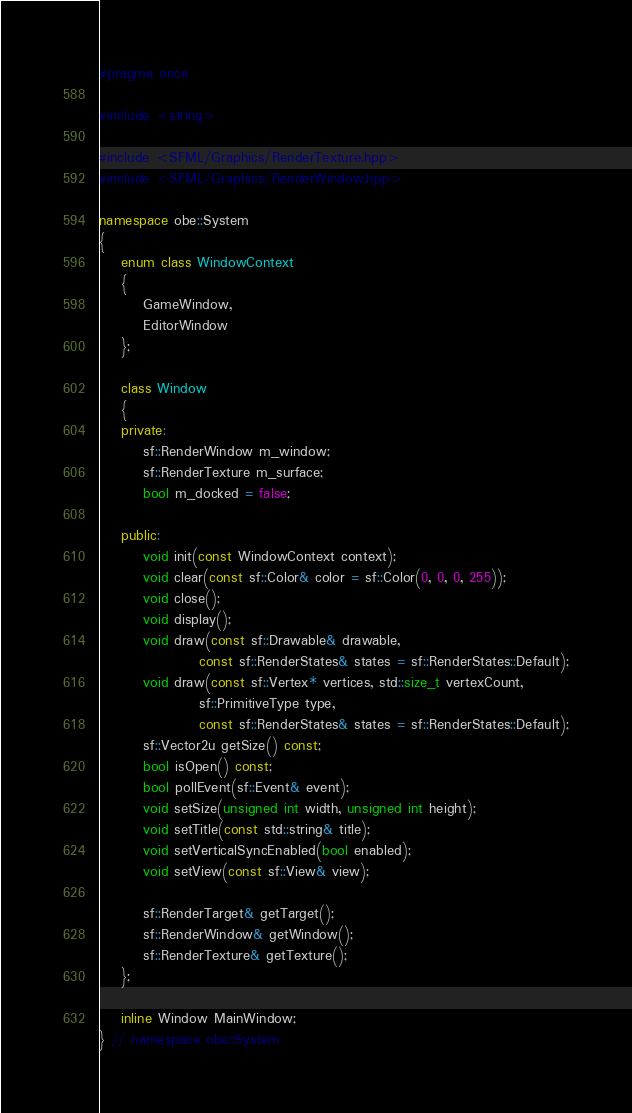Convert code to text. <code><loc_0><loc_0><loc_500><loc_500><_C++_>#pragma once

#include <string>

#include <SFML/Graphics/RenderTexture.hpp>
#include <SFML/Graphics/RenderWindow.hpp>

namespace obe::System
{
    enum class WindowContext
    {
        GameWindow,
        EditorWindow
    };

    class Window
    {
    private:
        sf::RenderWindow m_window;
        sf::RenderTexture m_surface;
        bool m_docked = false;

    public:
        void init(const WindowContext context);
        void clear(const sf::Color& color = sf::Color(0, 0, 0, 255));
        void close();
        void display();
        void draw(const sf::Drawable& drawable,
                  const sf::RenderStates& states = sf::RenderStates::Default);
        void draw(const sf::Vertex* vertices, std::size_t vertexCount,
                  sf::PrimitiveType type,
                  const sf::RenderStates& states = sf::RenderStates::Default);
        sf::Vector2u getSize() const;
        bool isOpen() const;
        bool pollEvent(sf::Event& event);
        void setSize(unsigned int width, unsigned int height);
        void setTitle(const std::string& title);
        void setVerticalSyncEnabled(bool enabled);
        void setView(const sf::View& view);

        sf::RenderTarget& getTarget();
        sf::RenderWindow& getWindow();
        sf::RenderTexture& getTexture();
    };

    inline Window MainWindow;
} // namespace obe::System</code> 